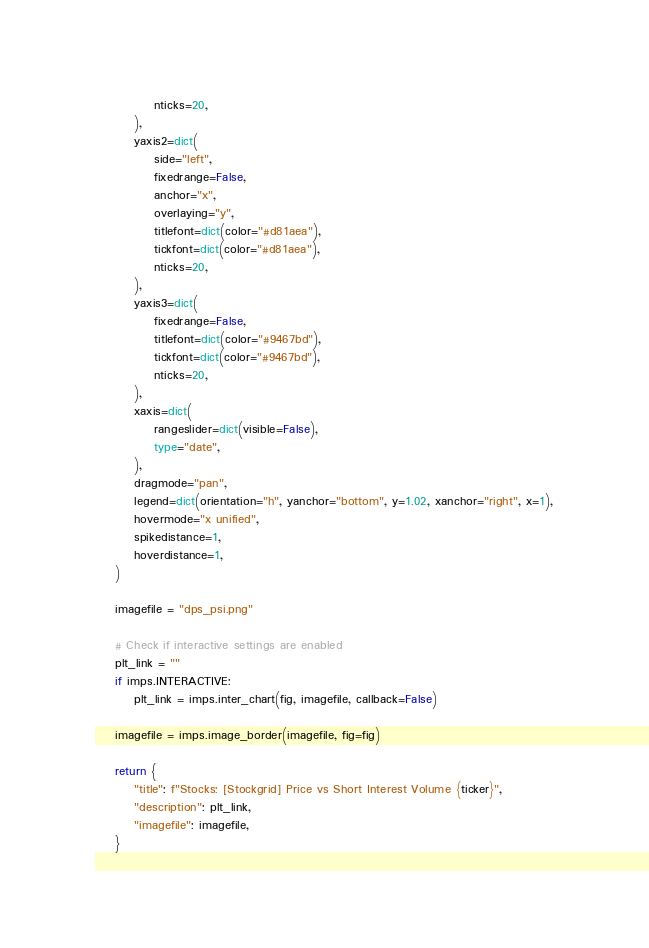<code> <loc_0><loc_0><loc_500><loc_500><_Python_>            nticks=20,
        ),
        yaxis2=dict(
            side="left",
            fixedrange=False,
            anchor="x",
            overlaying="y",
            titlefont=dict(color="#d81aea"),
            tickfont=dict(color="#d81aea"),
            nticks=20,
        ),
        yaxis3=dict(
            fixedrange=False,
            titlefont=dict(color="#9467bd"),
            tickfont=dict(color="#9467bd"),
            nticks=20,
        ),
        xaxis=dict(
            rangeslider=dict(visible=False),
            type="date",
        ),
        dragmode="pan",
        legend=dict(orientation="h", yanchor="bottom", y=1.02, xanchor="right", x=1),
        hovermode="x unified",
        spikedistance=1,
        hoverdistance=1,
    )

    imagefile = "dps_psi.png"

    # Check if interactive settings are enabled
    plt_link = ""
    if imps.INTERACTIVE:
        plt_link = imps.inter_chart(fig, imagefile, callback=False)

    imagefile = imps.image_border(imagefile, fig=fig)

    return {
        "title": f"Stocks: [Stockgrid] Price vs Short Interest Volume {ticker}",
        "description": plt_link,
        "imagefile": imagefile,
    }
</code> 